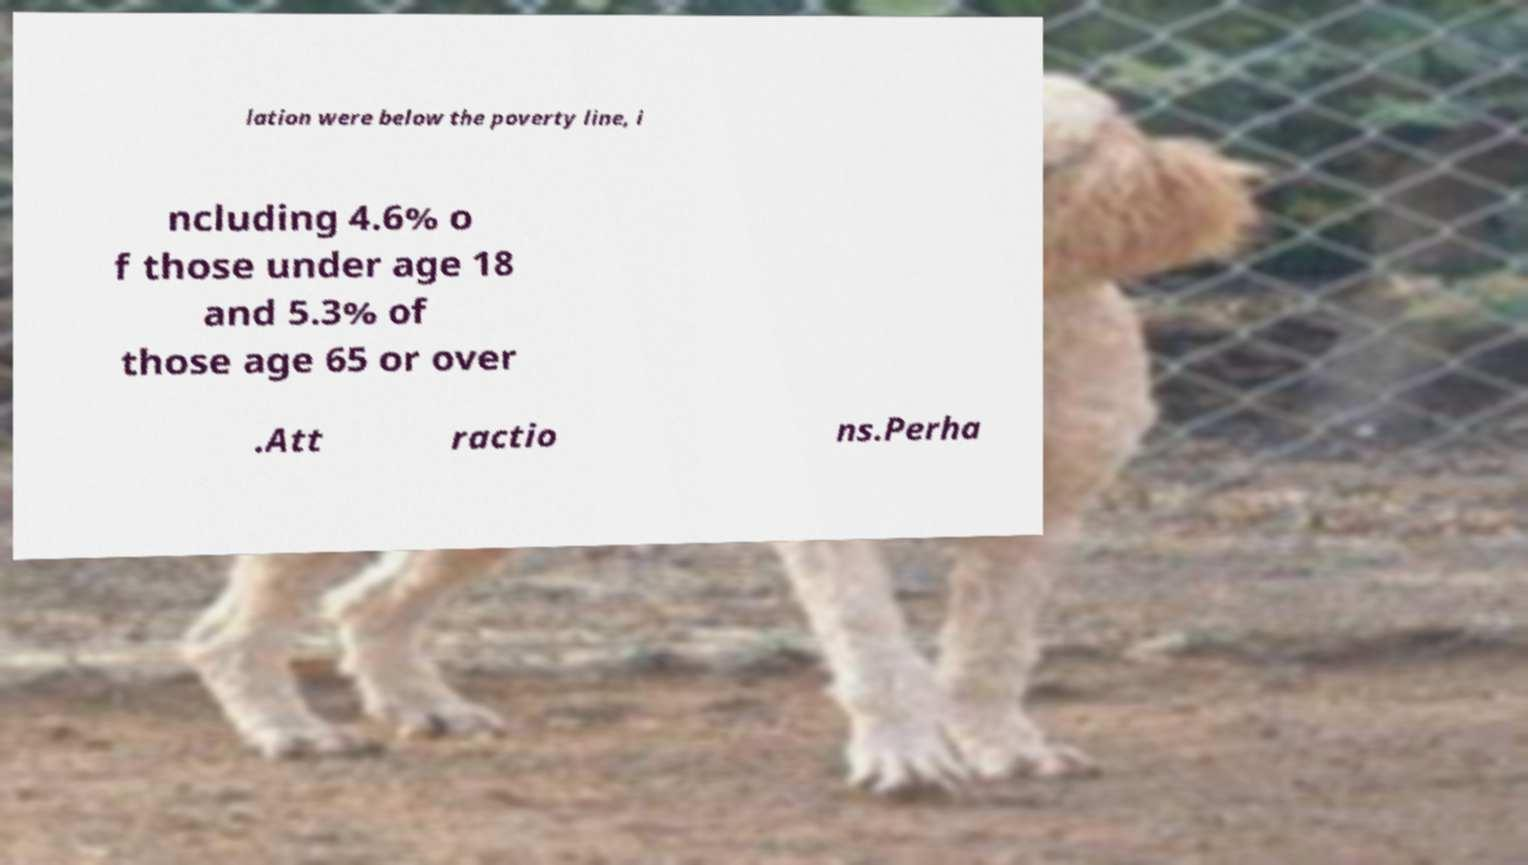Can you accurately transcribe the text from the provided image for me? lation were below the poverty line, i ncluding 4.6% o f those under age 18 and 5.3% of those age 65 or over .Att ractio ns.Perha 